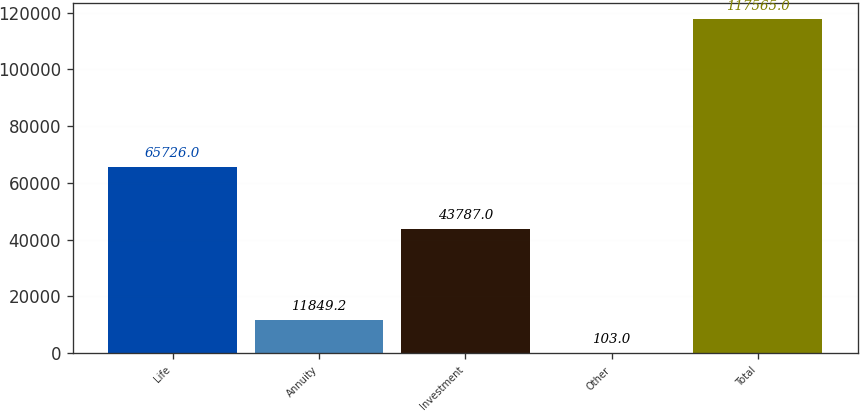<chart> <loc_0><loc_0><loc_500><loc_500><bar_chart><fcel>Life<fcel>Annuity<fcel>Investment<fcel>Other<fcel>Total<nl><fcel>65726<fcel>11849.2<fcel>43787<fcel>103<fcel>117565<nl></chart> 